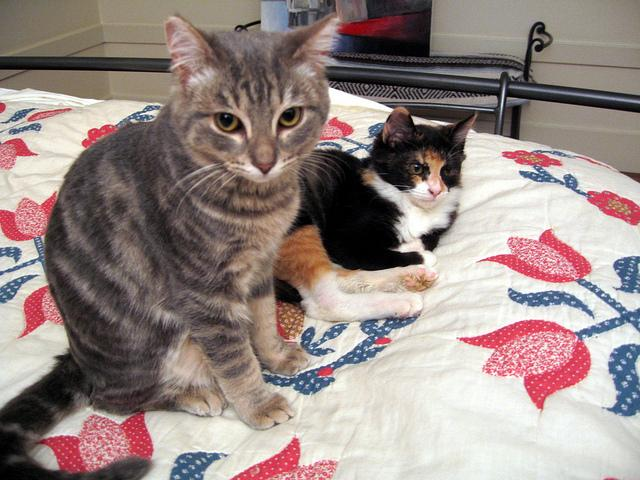What is the difference of these two cats?

Choices:
A) species
B) eyes
C) animal
D) breed breed 